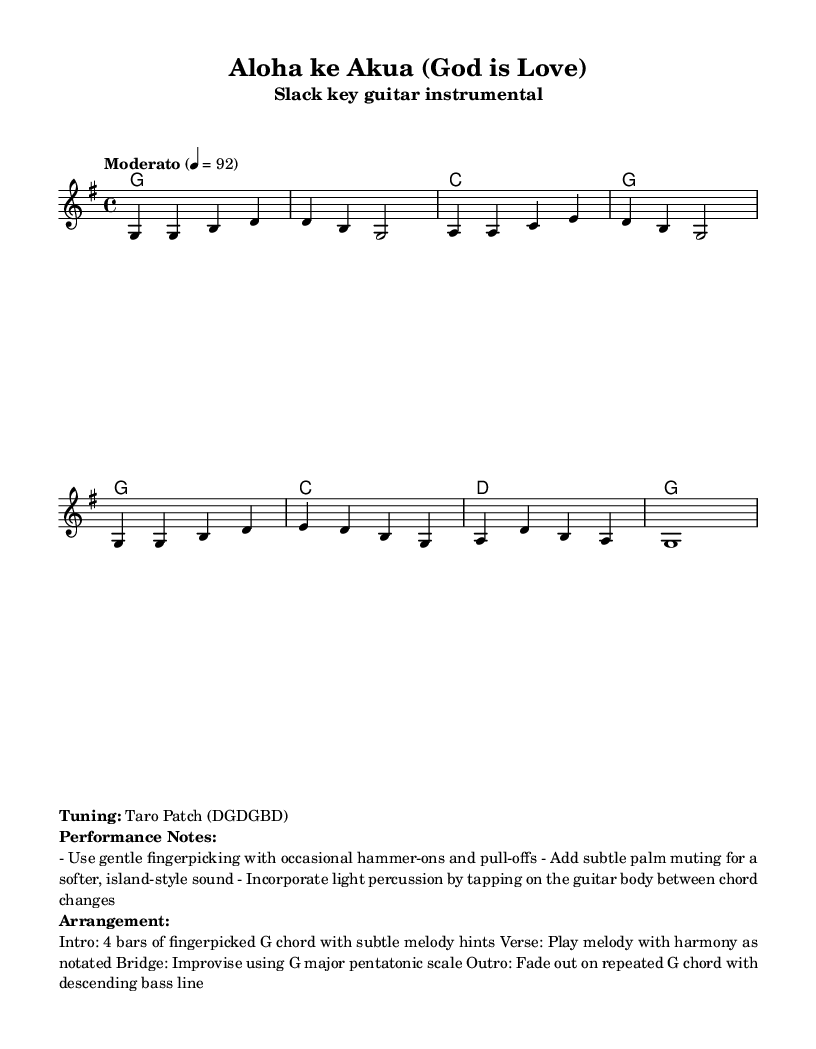What is the key signature of this music? The key signature is G major, which has one sharp, denoted by the presence of F#.
Answer: G major What is the time signature indicated in the sheet music? The time signature is 4/4, which indicates four beats per measure with a quarter note receiving one beat.
Answer: 4/4 What is the tempo marking for this piece? The tempo marking states "Moderato" at a speed of 92 beats per minute, indicating a moderate pace for playing the piece.
Answer: Moderato, 92 Which guitar tuning is specified for this arrangement? The arrangement notes a tuning of Taro Patch, which corresponds to the pitch DGDGBD.
Answer: Taro Patch (DGDGBD) How many bars are in the intro of the arrangement? The arrangement specifies an intro of 4 bars based on the instructions given for the performance.
Answer: 4 bars What type of technique is suggested for enhancing the musical sound during performance? The performance suggests using gentle fingerpicking with occasional hammer-ons and pull-offs to create a soft, flowing sound characteristic of slack key guitar.
Answer: Gentle fingerpicking What is the primary scale suggested for improvisation in the bridge? The bridge section encourages improvisation using the G major pentatonic scale, which consists of the notes G, A, B, D, and E.
Answer: G major pentatonic scale 